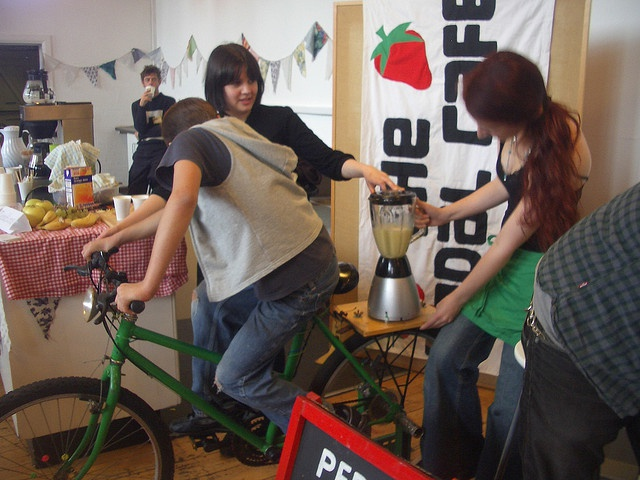Describe the objects in this image and their specific colors. I can see bicycle in gray, black, maroon, and darkgreen tones, people in gray, black, and darkgray tones, people in gray, black, maroon, and teal tones, people in gray, black, and purple tones, and people in gray, black, brown, maroon, and tan tones in this image. 